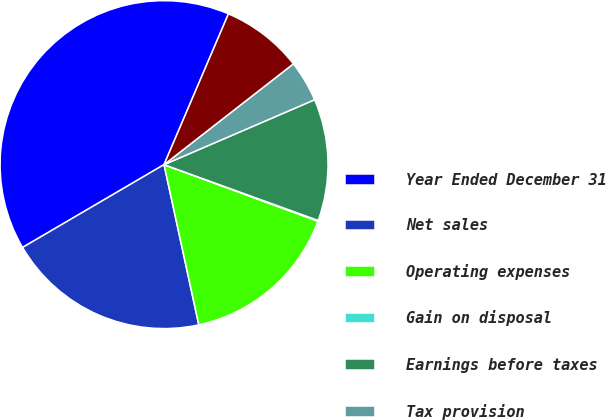Convert chart. <chart><loc_0><loc_0><loc_500><loc_500><pie_chart><fcel>Year Ended December 31<fcel>Net sales<fcel>Operating expenses<fcel>Gain on disposal<fcel>Earnings before taxes<fcel>Tax provision<fcel>(Loss) earnings from<nl><fcel>39.86%<fcel>19.97%<fcel>15.99%<fcel>0.08%<fcel>12.01%<fcel>4.06%<fcel>8.04%<nl></chart> 